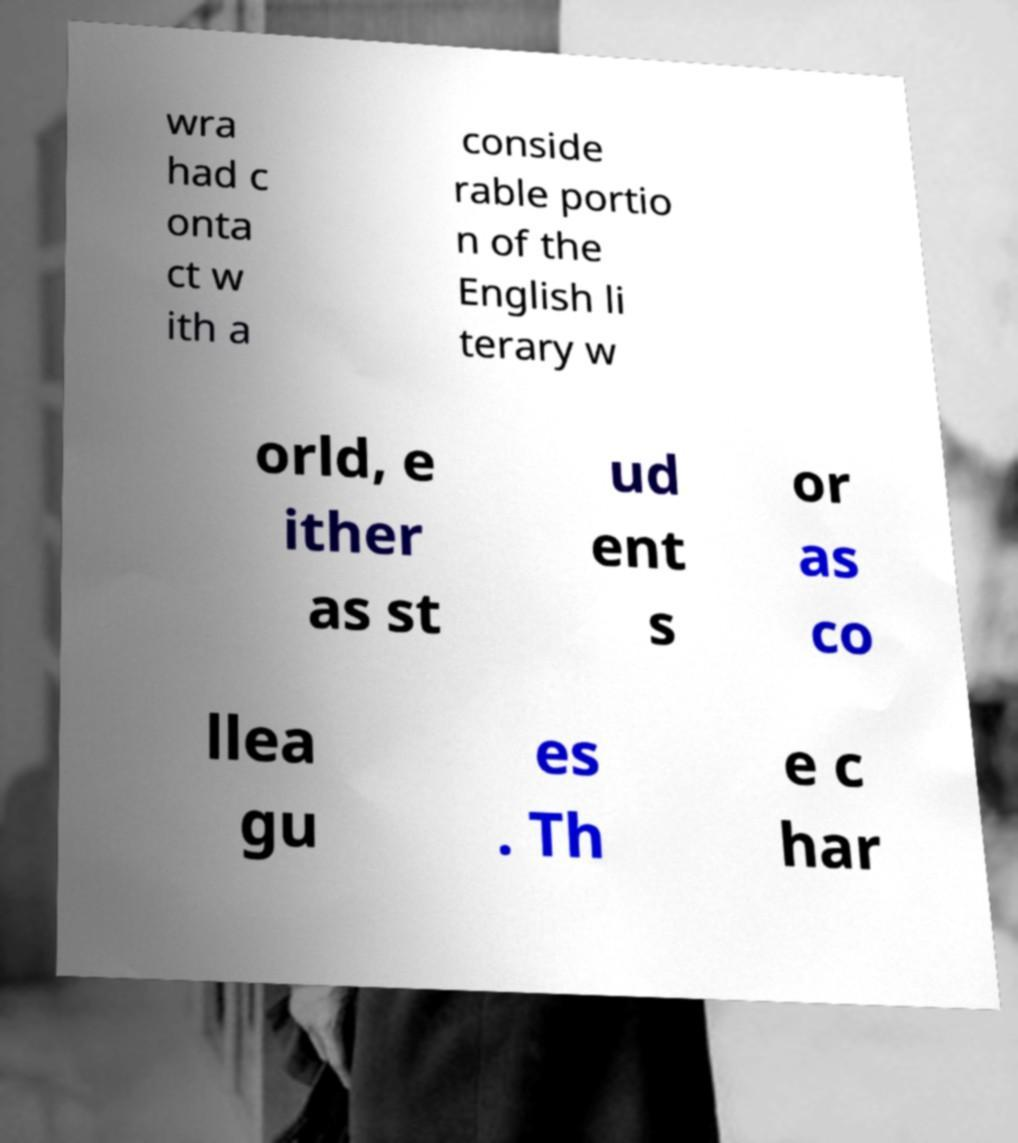Please identify and transcribe the text found in this image. wra had c onta ct w ith a conside rable portio n of the English li terary w orld, e ither as st ud ent s or as co llea gu es . Th e c har 